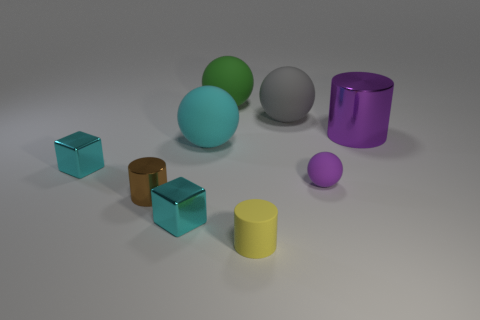Subtract all small purple matte spheres. How many spheres are left? 3 Add 1 rubber things. How many objects exist? 10 Subtract all blocks. How many objects are left? 7 Subtract all purple balls. How many balls are left? 3 Subtract 1 spheres. How many spheres are left? 3 Add 7 yellow cylinders. How many yellow cylinders exist? 8 Subtract 0 blue cylinders. How many objects are left? 9 Subtract all purple balls. Subtract all brown cylinders. How many balls are left? 3 Subtract all green spheres. How many blue cylinders are left? 0 Subtract all large cyan things. Subtract all brown shiny cylinders. How many objects are left? 7 